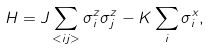<formula> <loc_0><loc_0><loc_500><loc_500>H = J \sum _ { < i j > } \sigma ^ { z } _ { i } \sigma ^ { z } _ { j } - K \sum _ { i } \sigma ^ { x } _ { i } ,</formula> 